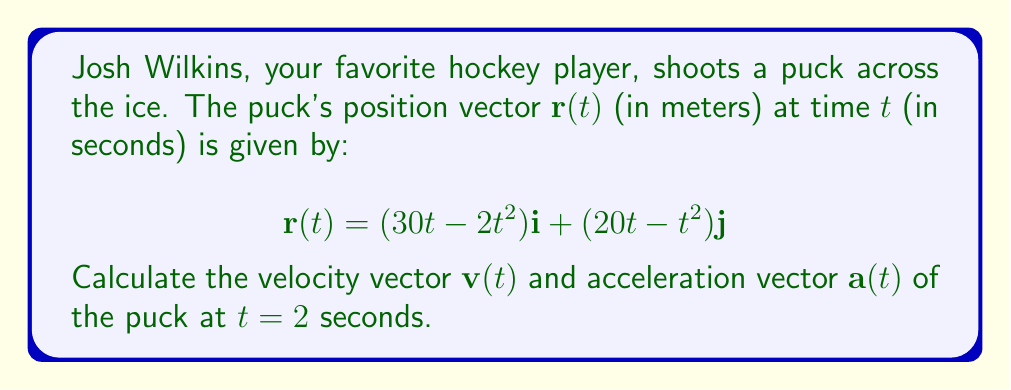Give your solution to this math problem. To solve this problem, we'll use vector calculus:

1. Velocity vector:
The velocity vector $\mathbf{v}(t)$ is the first derivative of the position vector $\mathbf{r}(t)$ with respect to time:

$$\mathbf{v}(t) = \frac{d\mathbf{r}}{dt} = (30 - 4t)\mathbf{i} + (20 - 2t)\mathbf{j}$$

2. Acceleration vector:
The acceleration vector $\mathbf{a}(t)$ is the second derivative of the position vector $\mathbf{r}(t)$ or the first derivative of the velocity vector $\mathbf{v}(t)$:

$$\mathbf{a}(t) = \frac{d\mathbf{v}}{dt} = -4\mathbf{i} - 2\mathbf{j}$$

3. Evaluate at $t = 2$ seconds:

Velocity at $t = 2$:
$$\mathbf{v}(2) = (30 - 4(2))\mathbf{i} + (20 - 2(2))\mathbf{j} = 22\mathbf{i} + 16\mathbf{j}$$

Acceleration at $t = 2$:
$$\mathbf{a}(2) = -4\mathbf{i} - 2\mathbf{j}$$

Note that the acceleration is constant and doesn't depend on time.
Answer: $\mathbf{v}(2) = 22\mathbf{i} + 16\mathbf{j}$ m/s, $\mathbf{a}(2) = -4\mathbf{i} - 2\mathbf{j}$ m/s² 